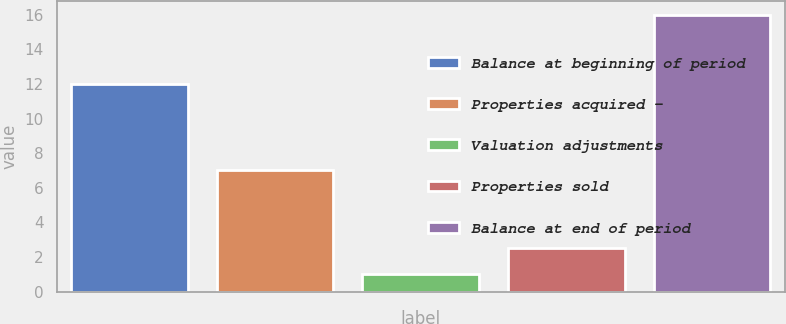<chart> <loc_0><loc_0><loc_500><loc_500><bar_chart><fcel>Balance at beginning of period<fcel>Properties acquired -<fcel>Valuation adjustments<fcel>Properties sold<fcel>Balance at end of period<nl><fcel>12<fcel>7<fcel>1<fcel>2.5<fcel>16<nl></chart> 